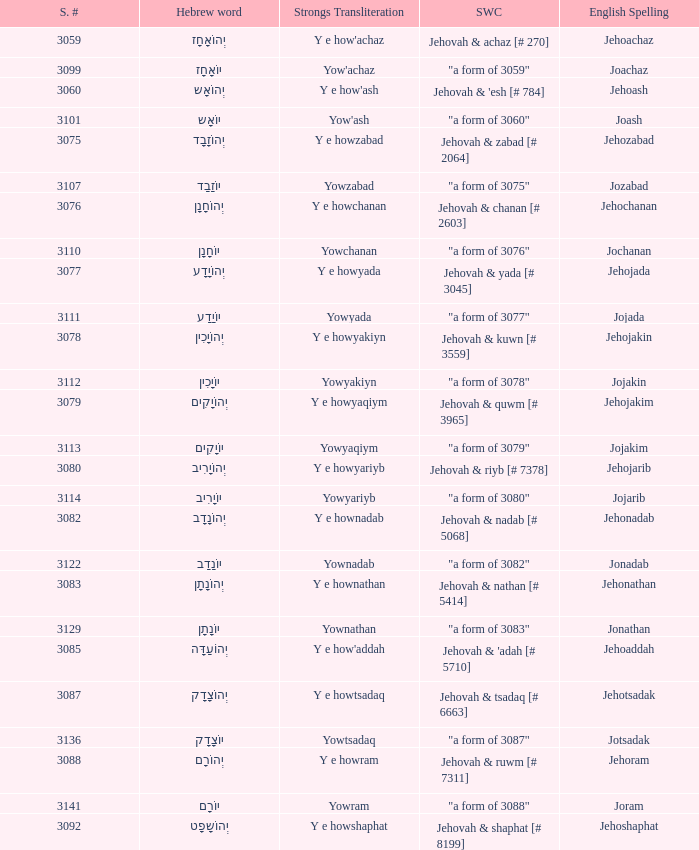What is the strongs # of the english spelling word jehojakin? 3078.0. 